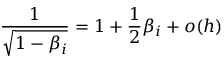Convert formula to latex. <formula><loc_0><loc_0><loc_500><loc_500>\frac { 1 } { \sqrt { 1 - \beta _ { i } } } = 1 + \frac { 1 } { 2 } \beta _ { i } + o ( h )</formula> 